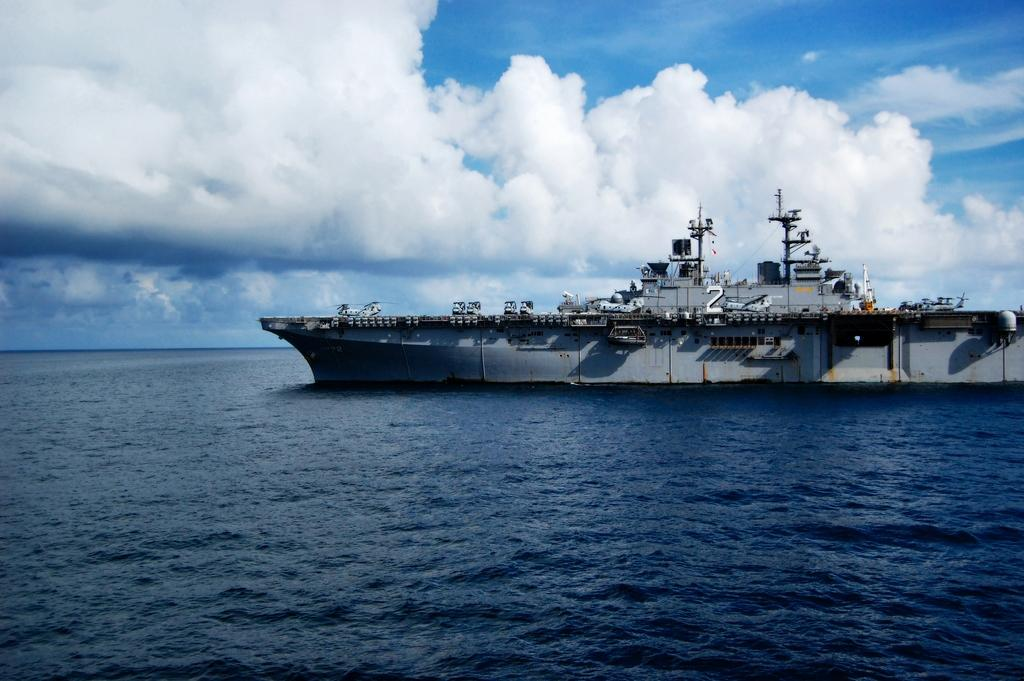What type of vehicles can be seen in the image? There are vehicles on a naval ship in the image. Where is the naval ship located? The naval ship is on the water. What can be seen in the background of the image? The sky is visible in the background of the image. What is the company's annual income in the image? There is no information about a company or its income in the image. The image features a naval ship with vehicles on it, located on the water with the sky visible in the background. 